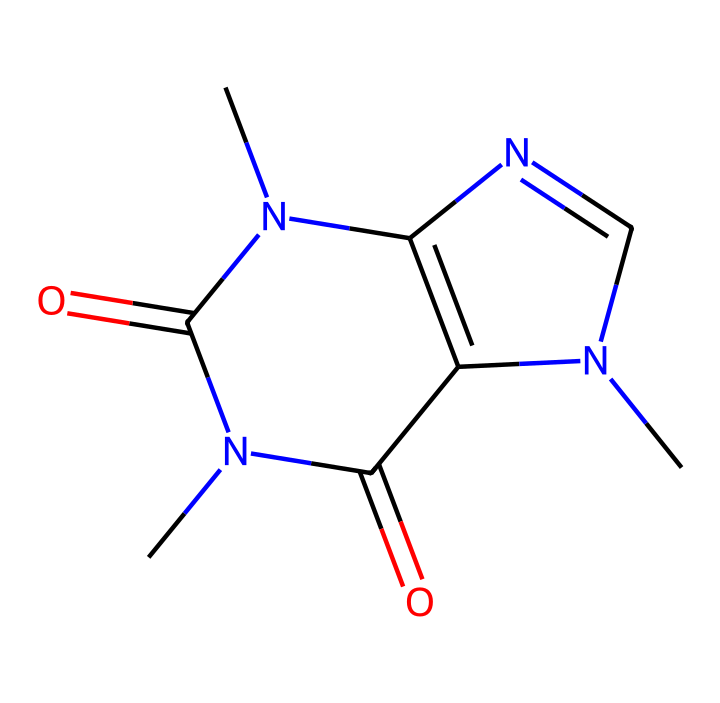What is the chemical name of this compound? The SMILES representation corresponds to caffeine, which is a well-known stimulant found in coffee and tea. The structure reveals the arrangement of atoms, confirming it as caffeine.
Answer: caffeine How many rings are present in the structure? By analyzing the structure, it shows two fused rings in the molecule. The nitrogen and carbon atoms indicate the cyclic nature of the compound.
Answer: two How many nitrogen atoms are in the caffeine structure? Upon reflecting on the SMILES notation, there are three nitrogen atoms present in the structure. Counting these confirms their presence.
Answer: three What type of compound is caffeine classified as? Caffeine is classified as an alkaloid due to its basic nitrogen atoms and physiological effects as a stimulant, commonly associated with biological activities.
Answer: alkaloid Does the structure contain carbonyl (C=O) groups? Yes, reviewing the structure shows the presence of two carbonyl groups (C=O) located on specific carbon atoms, which are characteristic of the carbonyl functional group.
Answer: yes How many total carbon atoms are present in the caffeine molecule? By counting the carbon atoms in the SMILES representation, it sums up to eight carbon atoms in the entire structure.
Answer: eight What characteristics do the aromatic rings in caffeine impart? The presence of aromatic rings provides stability and unique chemical properties, such as solubility and reactivity, distinguishing caffeine from non-aromatic compounds.
Answer: stability 